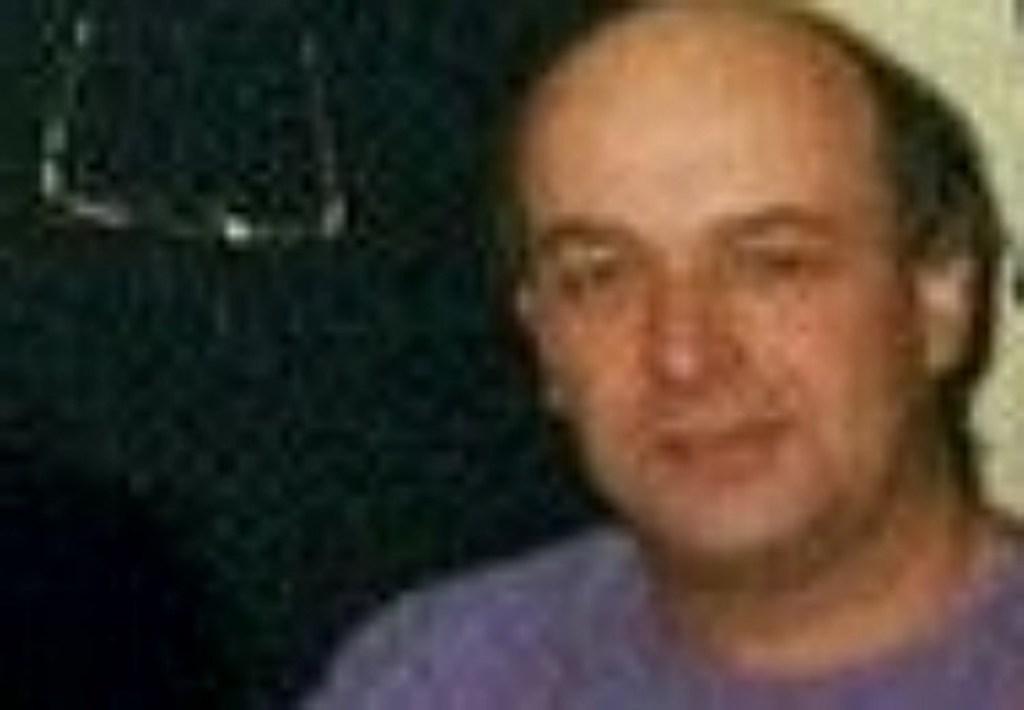In one or two sentences, can you explain what this image depicts? In this image we can see a person and the background is blurred. 